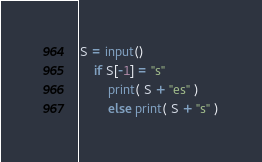Convert code to text. <code><loc_0><loc_0><loc_500><loc_500><_Python_>S = input()
	if S[-1] = "s"
		print( S + "es" )
		else print( S + "s" )</code> 